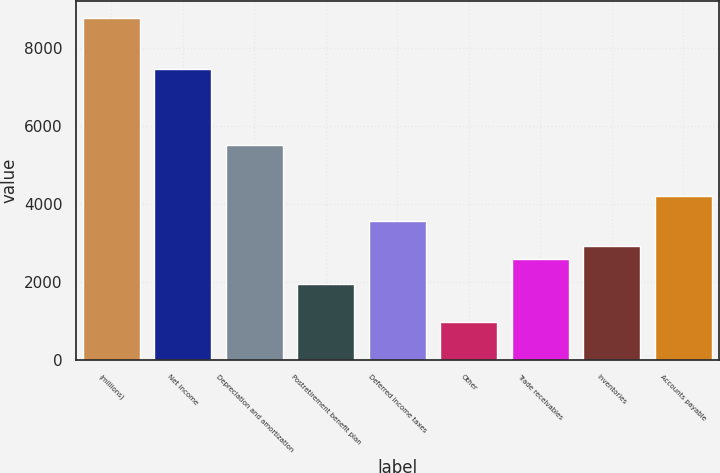Convert chart. <chart><loc_0><loc_0><loc_500><loc_500><bar_chart><fcel>(millions)<fcel>Net income<fcel>Depreciation and amortization<fcel>Postretirement benefit plan<fcel>Deferred income taxes<fcel>Other<fcel>Trade receivables<fcel>Inventories<fcel>Accounts payable<nl><fcel>8759.8<fcel>7462.2<fcel>5515.8<fcel>1947.4<fcel>3569.4<fcel>974.2<fcel>2596.2<fcel>2920.6<fcel>4218.2<nl></chart> 